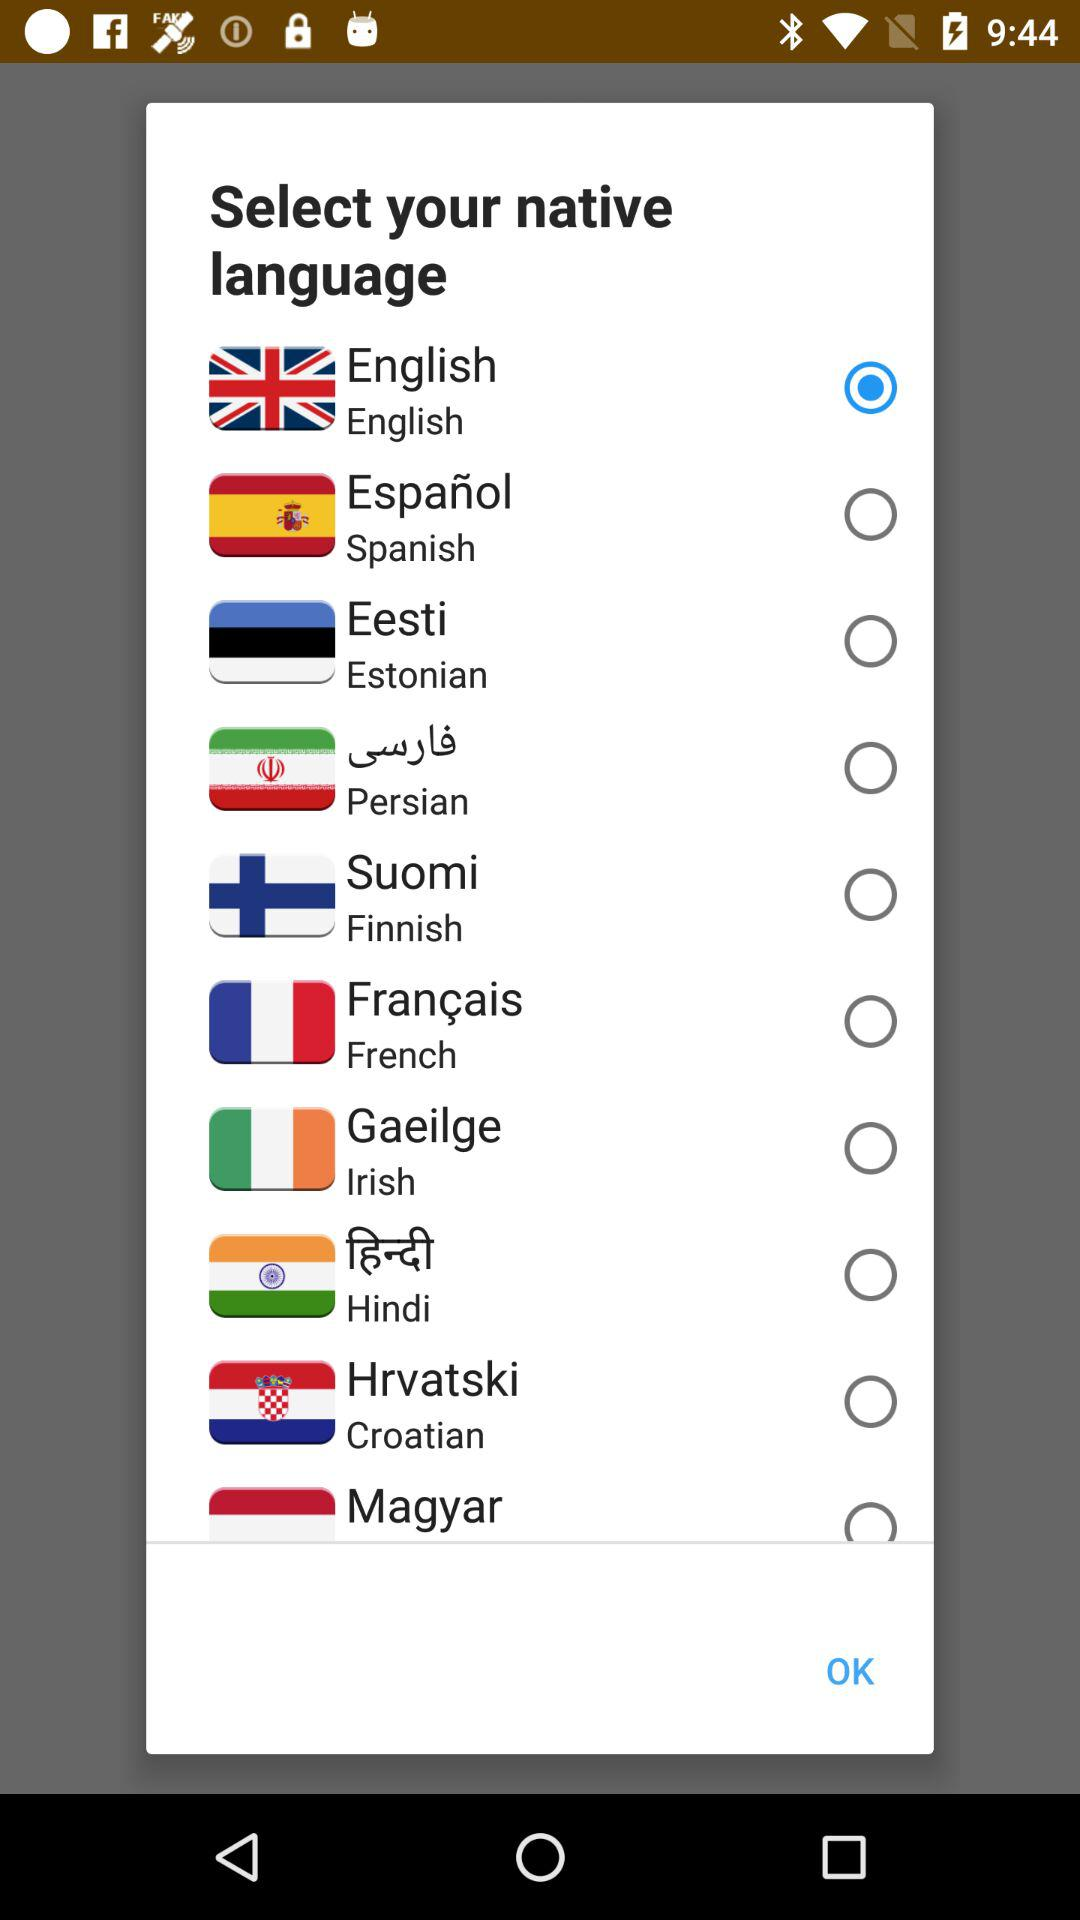How many languages are available to select from?
Answer the question using a single word or phrase. 10 